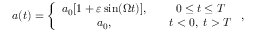<formula> <loc_0><loc_0><loc_500><loc_500>a ( t ) = \left \{ \begin{array} { c c } { { a _ { 0 } [ 1 + \varepsilon \sin ( \Omega t ) ] , } } & { \quad 0 \leq t \leq T } \\ { { a _ { 0 } , } } & { \quad t < 0 , \, t > T } \end{array} ,</formula> 